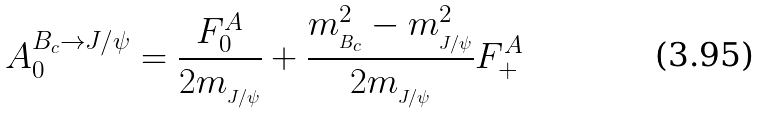Convert formula to latex. <formula><loc_0><loc_0><loc_500><loc_500>A _ { 0 } ^ { B _ { c } { \to } J / { \psi } } = \frac { F _ { 0 } ^ { A } } { 2 m _ { _ { J / { \psi } } } } + \frac { m _ { _ { B _ { c } } } ^ { 2 } - m _ { _ { J / { \psi } } } ^ { 2 } } { 2 m _ { _ { J / { \psi } } } } F _ { + } ^ { A }</formula> 